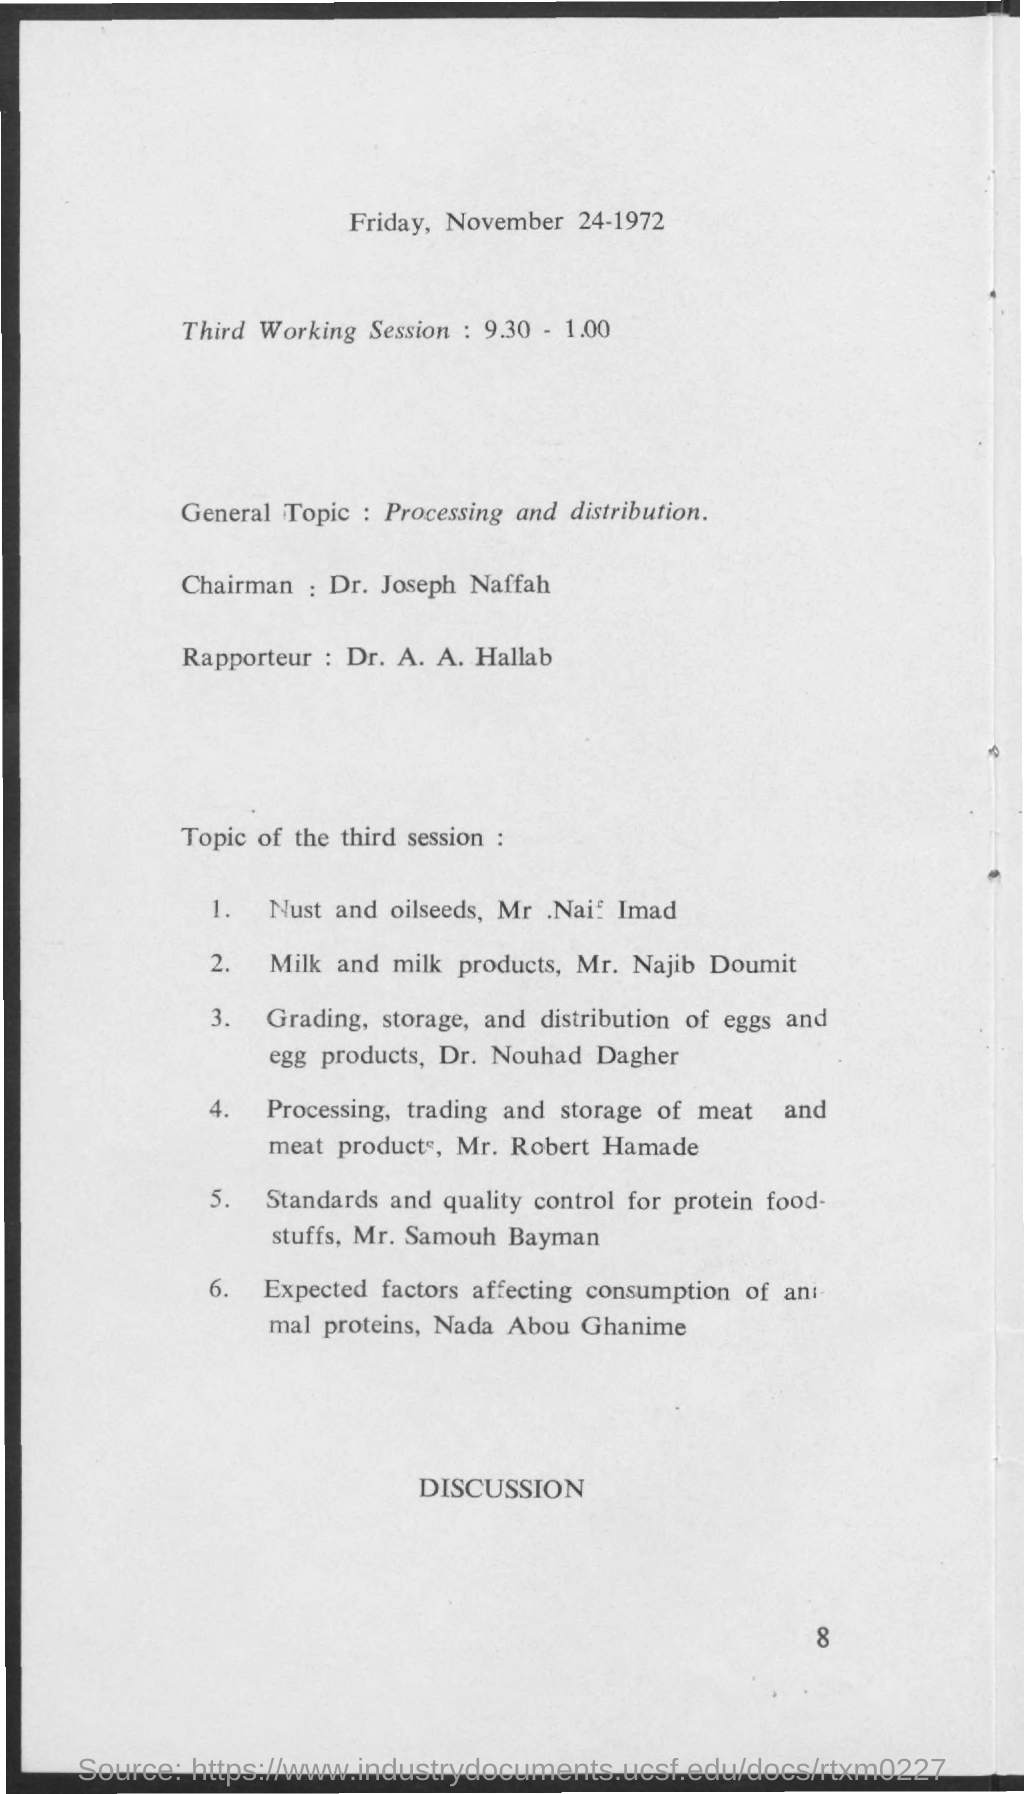What is the date mentioned in the given page ?
Make the answer very short. Friday, november 24-1972. What is the general topic mentioned ?
Provide a short and direct response. Processing and distribution. What is the name of the chairman mentioned ?
Keep it short and to the point. Dr. Joseph Naffah. 